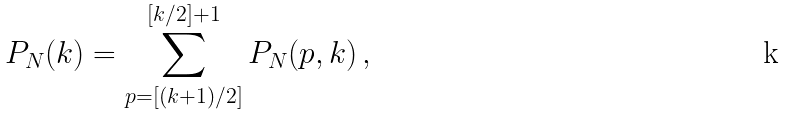<formula> <loc_0><loc_0><loc_500><loc_500>P _ { N } ( k ) = \sum _ { p = [ ( k + 1 ) / 2 ] } ^ { [ k / 2 ] + 1 } P _ { N } ( p , k ) \, ,</formula> 